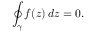<formula> <loc_0><loc_0><loc_500><loc_500>\oint _ { \gamma } f ( z ) \, d z = 0 .</formula> 